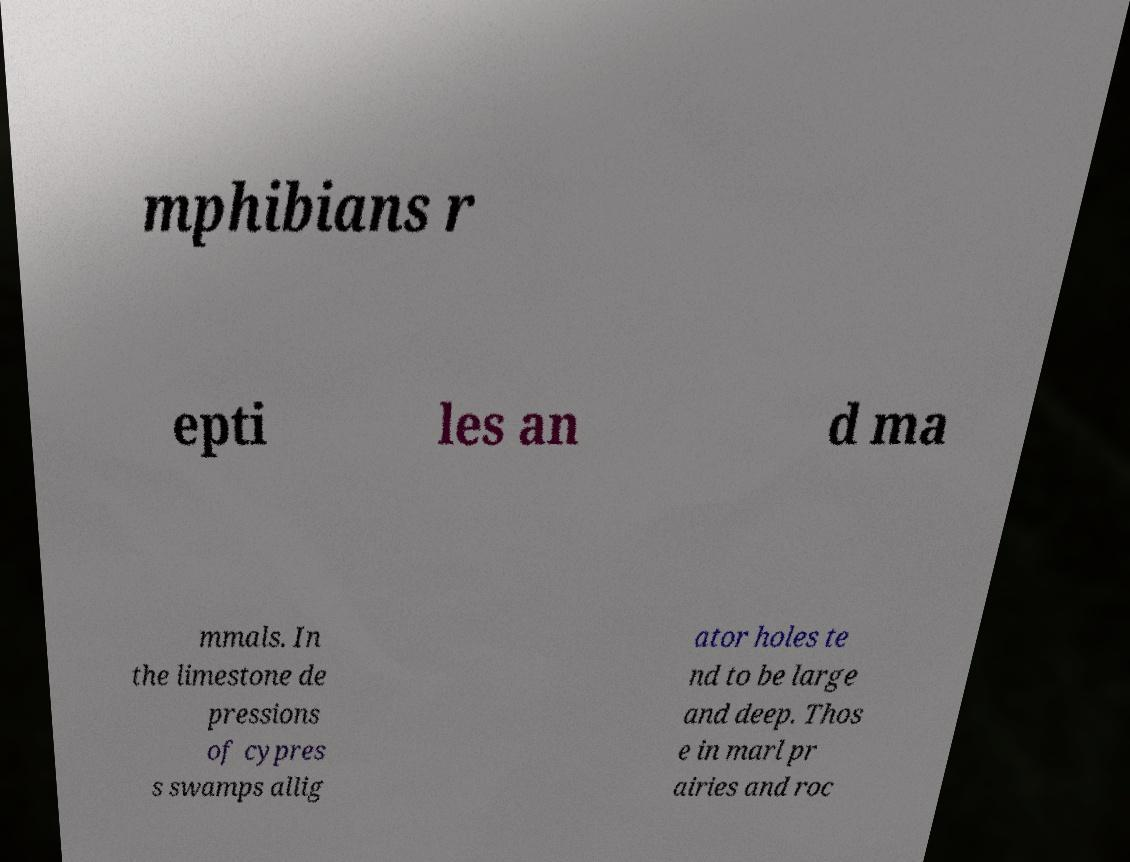There's text embedded in this image that I need extracted. Can you transcribe it verbatim? mphibians r epti les an d ma mmals. In the limestone de pressions of cypres s swamps allig ator holes te nd to be large and deep. Thos e in marl pr airies and roc 